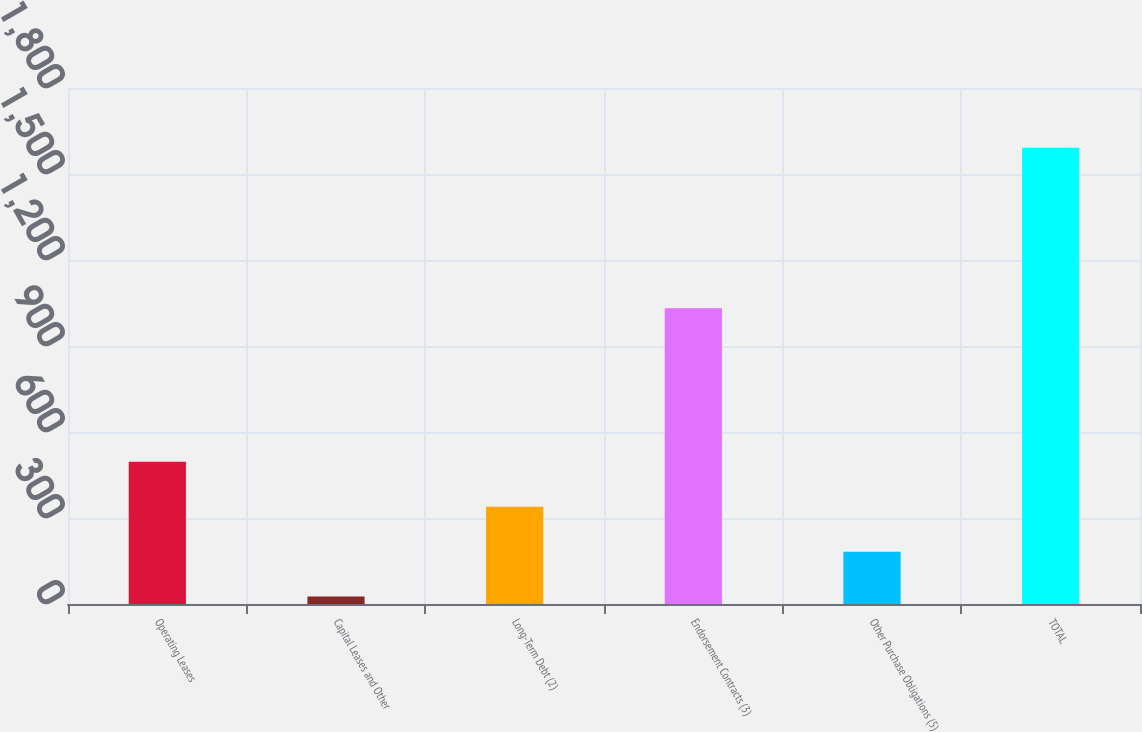Convert chart to OTSL. <chart><loc_0><loc_0><loc_500><loc_500><bar_chart><fcel>Operating Leases<fcel>Capital Leases and Other<fcel>Long-Term Debt (2)<fcel>Endorsement Contracts (3)<fcel>Other Purchase Obligations (5)<fcel>TOTAL<nl><fcel>495.8<fcel>26<fcel>339.2<fcel>1032<fcel>182.6<fcel>1592<nl></chart> 